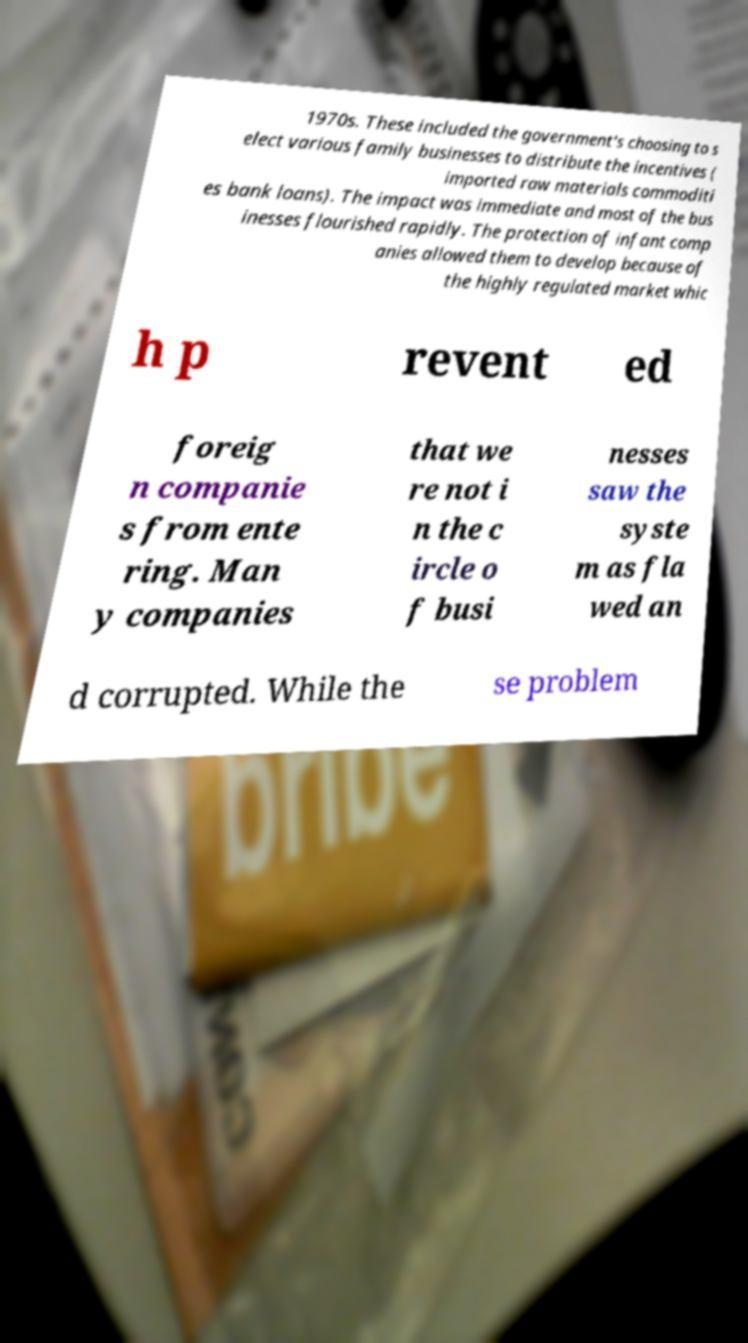Can you read and provide the text displayed in the image?This photo seems to have some interesting text. Can you extract and type it out for me? 1970s. These included the government's choosing to s elect various family businesses to distribute the incentives ( imported raw materials commoditi es bank loans). The impact was immediate and most of the bus inesses flourished rapidly. The protection of infant comp anies allowed them to develop because of the highly regulated market whic h p revent ed foreig n companie s from ente ring. Man y companies that we re not i n the c ircle o f busi nesses saw the syste m as fla wed an d corrupted. While the se problem 